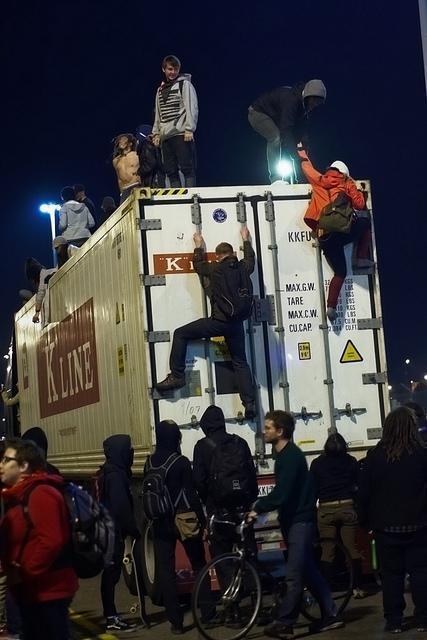How many backpacks can be seen?
Give a very brief answer. 2. How many people are there?
Give a very brief answer. 12. 